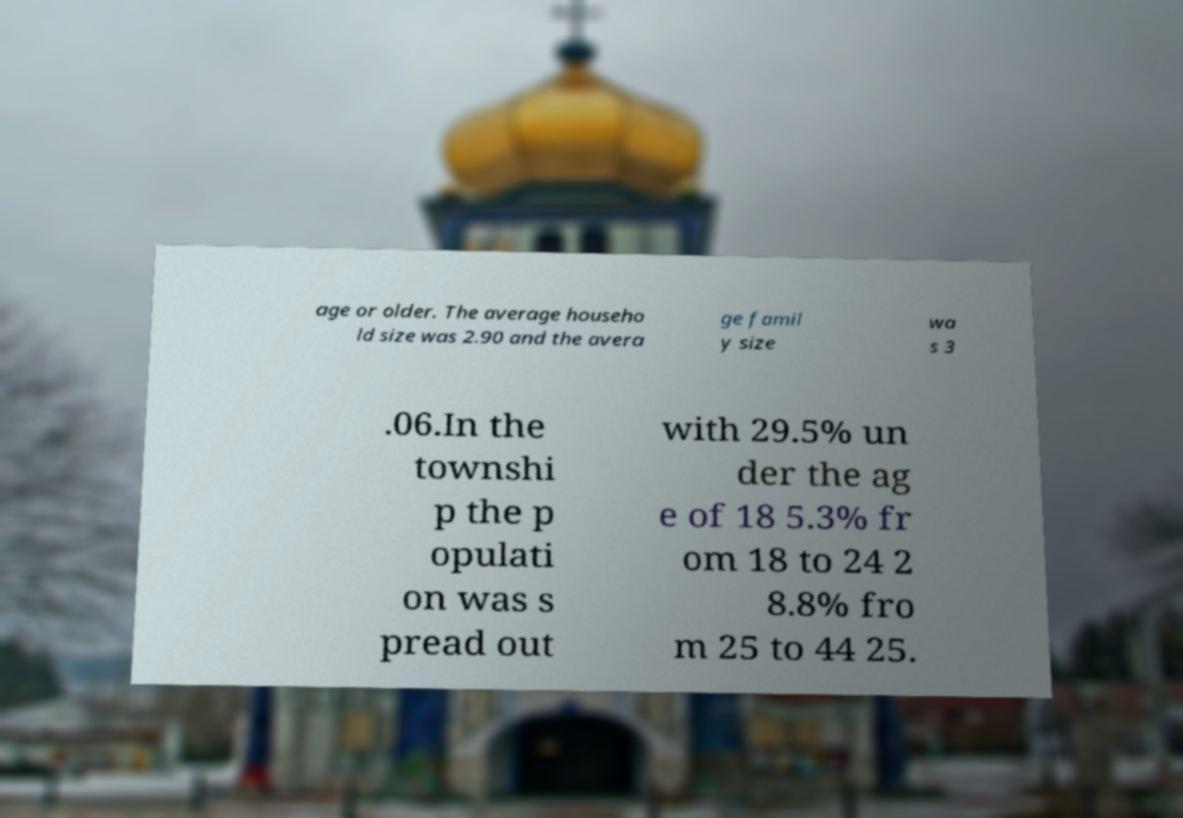Please identify and transcribe the text found in this image. age or older. The average househo ld size was 2.90 and the avera ge famil y size wa s 3 .06.In the townshi p the p opulati on was s pread out with 29.5% un der the ag e of 18 5.3% fr om 18 to 24 2 8.8% fro m 25 to 44 25. 